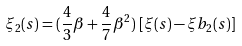<formula> <loc_0><loc_0><loc_500><loc_500>\xi _ { 2 } ( s ) = ( \frac { 4 } { 3 } \beta + \frac { 4 } { 7 } \beta ^ { 2 } ) \, \left [ \xi ( s ) - \xi b _ { 2 } ( s ) \right ]</formula> 